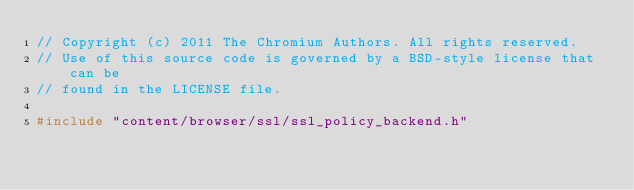Convert code to text. <code><loc_0><loc_0><loc_500><loc_500><_C++_>// Copyright (c) 2011 The Chromium Authors. All rights reserved.
// Use of this source code is governed by a BSD-style license that can be
// found in the LICENSE file.

#include "content/browser/ssl/ssl_policy_backend.h"
</code> 